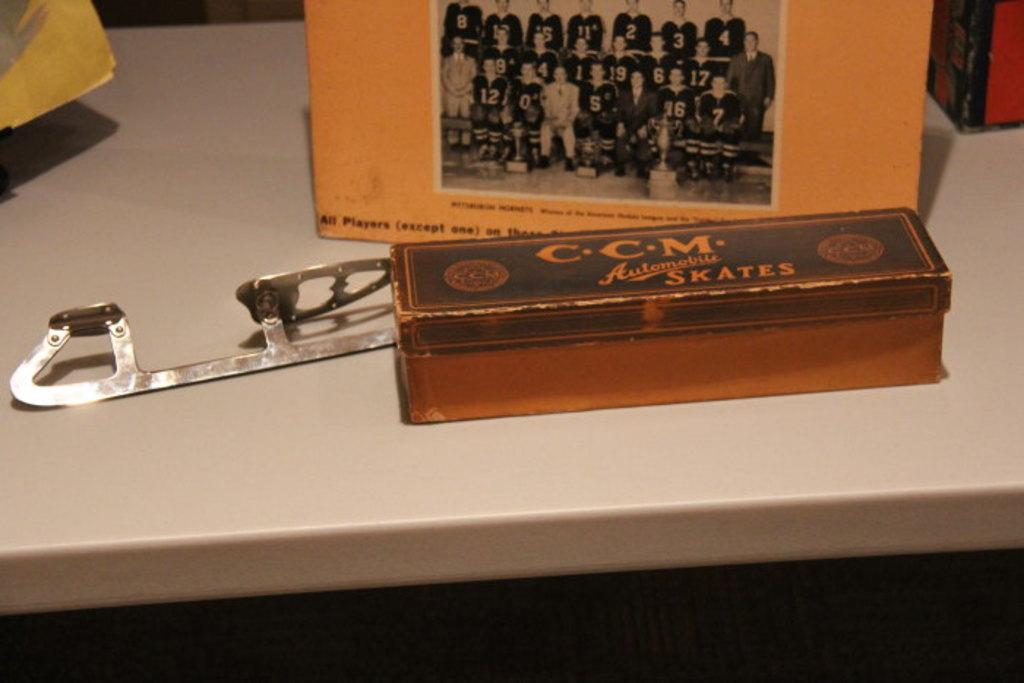<image>
Provide a brief description of the given image. Old ice skate blade is shown behind a box that says "CCM Skates." 